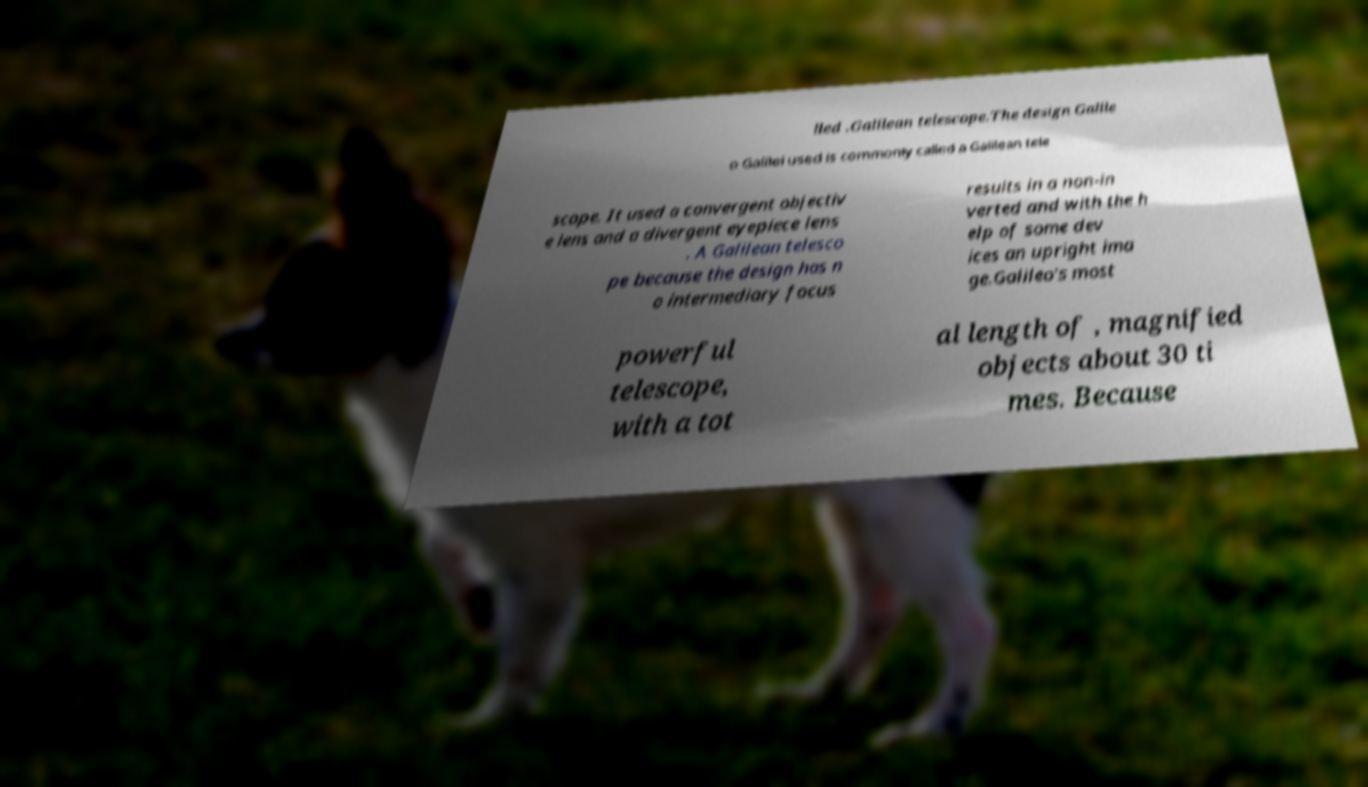Can you accurately transcribe the text from the provided image for me? lled .Galilean telescope.The design Galile o Galilei used is commonly called a Galilean tele scope. It used a convergent objectiv e lens and a divergent eyepiece lens . A Galilean telesco pe because the design has n o intermediary focus results in a non-in verted and with the h elp of some dev ices an upright ima ge.Galileo's most powerful telescope, with a tot al length of , magnified objects about 30 ti mes. Because 